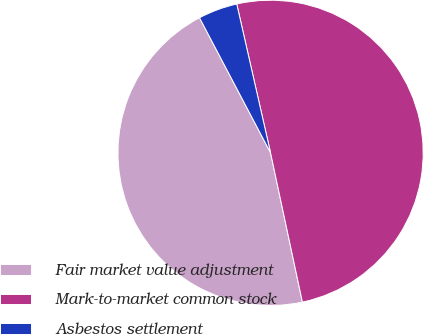Convert chart. <chart><loc_0><loc_0><loc_500><loc_500><pie_chart><fcel>Fair market value adjustment<fcel>Mark-to-market common stock<fcel>Asbestos settlement<nl><fcel>45.64%<fcel>50.21%<fcel>4.15%<nl></chart> 